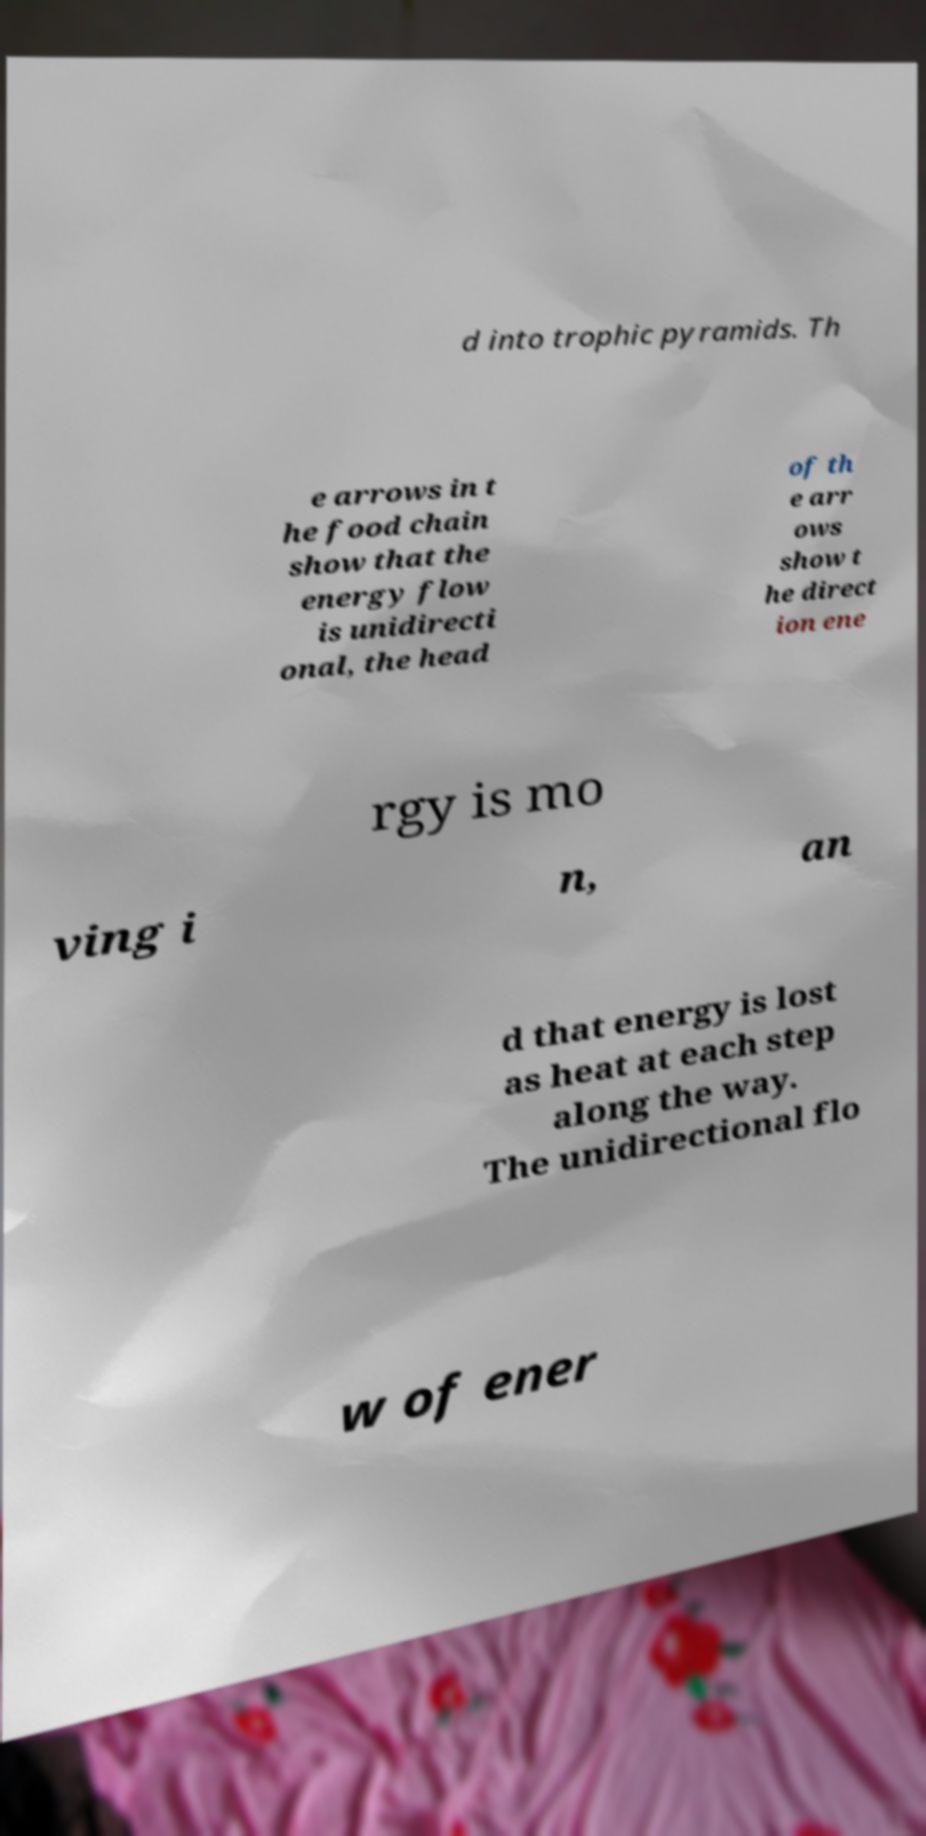Could you extract and type out the text from this image? d into trophic pyramids. Th e arrows in t he food chain show that the energy flow is unidirecti onal, the head of th e arr ows show t he direct ion ene rgy is mo ving i n, an d that energy is lost as heat at each step along the way. The unidirectional flo w of ener 